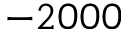<formula> <loc_0><loc_0><loc_500><loc_500>- 2 0 0 0</formula> 